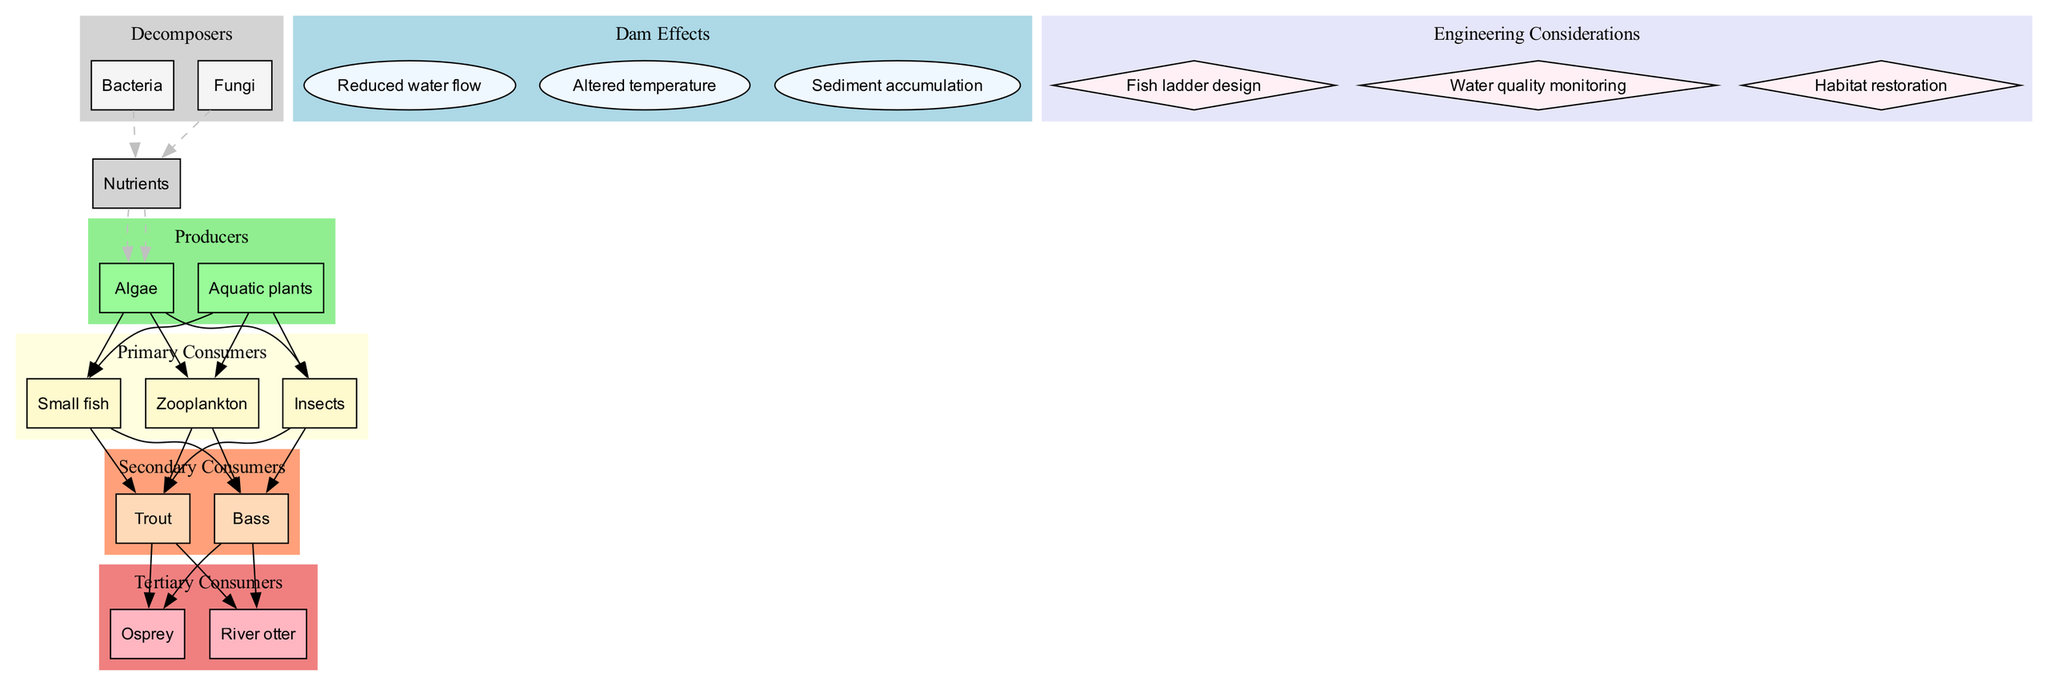What are the primary consumers in the river food web? The diagram lists the primary consumers in a cluster. They are shown as distinct nodes: Zooplankton, Insects, and Small fish.
Answer: Zooplankton, Insects, Small fish Which organism is a tertiary consumer? The tertiary consumers are indicated in a separate cluster in the diagram. The organisms listed are Osprey and River otter. Any one of these can be considered as a correct answer.
Answer: Osprey How many producers are in the diagram? The producers are presented in their own cluster. By counting the number of nodes in that cluster, we find there are 2 producers: Algae and Aquatic plants.
Answer: 2 What effect does dam construction have on water flow? The effects of the dam construction are shown in a separate cluster. One of the nodes specifically states "Reduced water flow" as a direct consequence of the dam.
Answer: Reduced water flow What relationship exists between small fish and trout? In the diagram, small fish are connected with an edge leading to trout, indicating that small fish are preyed upon by trout, establishing a feeding relationship.
Answer: Small fish are prey for trout How many decomposers are there in the food web? The decomposers are represented in their own cluster, and upon examination, there are two decomposers listed: Bacteria and Fungi.
Answer: 2 What is a key engineering consideration mentioned in the diagram? The engineering considerations are listed in a defined cluster. One example of these considerations is "Fish ladder design," which is important for facilitating fish migration.
Answer: Fish ladder design What happens to nutrients after decomposition? The relationship is depicted in the diagram where decomposers such as bacteria and fungi lead to nutrients. These nutrients are then shown to cycle back to producers, thus enriching the ecosystem.
Answer: Nutrients return to producers Which secondary consumer is linked to bass? In the diagram, bass is shown as one of the secondary consumers linked to primary consumers, specifically receiving nutrients through the food chain that connects them with smaller fish and insects.
Answer: Bass 